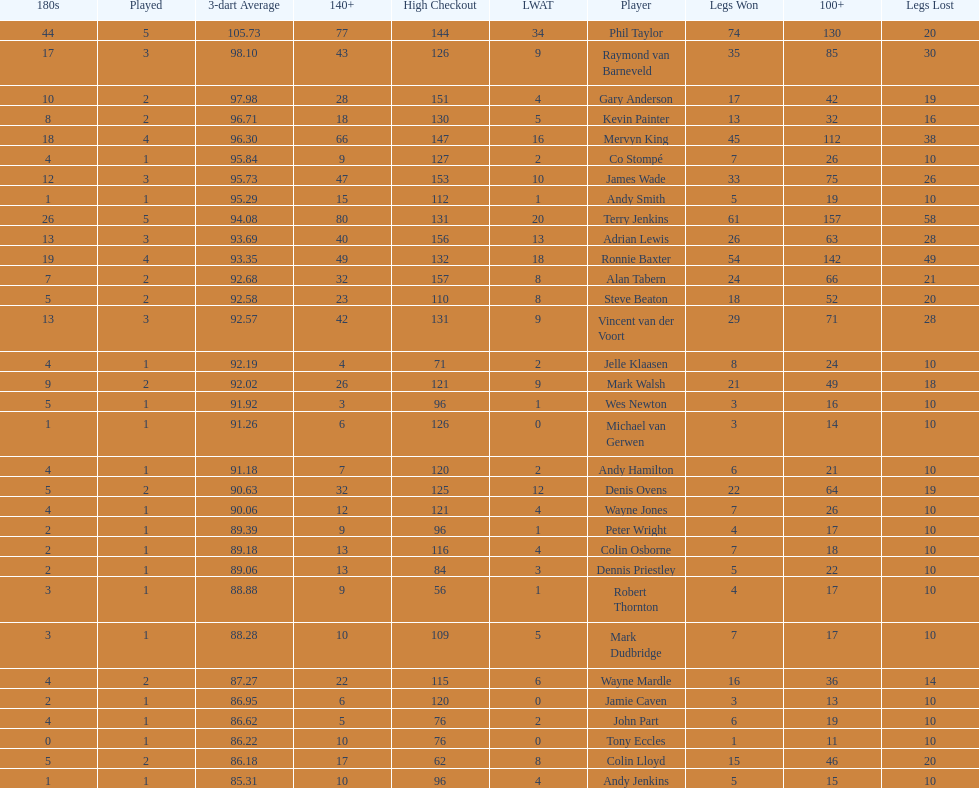Could you parse the entire table? {'header': ['180s', 'Played', '3-dart Average', '140+', 'High Checkout', 'LWAT', 'Player', 'Legs Won', '100+', 'Legs Lost'], 'rows': [['44', '5', '105.73', '77', '144', '34', 'Phil Taylor', '74', '130', '20'], ['17', '3', '98.10', '43', '126', '9', 'Raymond van Barneveld', '35', '85', '30'], ['10', '2', '97.98', '28', '151', '4', 'Gary Anderson', '17', '42', '19'], ['8', '2', '96.71', '18', '130', '5', 'Kevin Painter', '13', '32', '16'], ['18', '4', '96.30', '66', '147', '16', 'Mervyn King', '45', '112', '38'], ['4', '1', '95.84', '9', '127', '2', 'Co Stompé', '7', '26', '10'], ['12', '3', '95.73', '47', '153', '10', 'James Wade', '33', '75', '26'], ['1', '1', '95.29', '15', '112', '1', 'Andy Smith', '5', '19', '10'], ['26', '5', '94.08', '80', '131', '20', 'Terry Jenkins', '61', '157', '58'], ['13', '3', '93.69', '40', '156', '13', 'Adrian Lewis', '26', '63', '28'], ['19', '4', '93.35', '49', '132', '18', 'Ronnie Baxter', '54', '142', '49'], ['7', '2', '92.68', '32', '157', '8', 'Alan Tabern', '24', '66', '21'], ['5', '2', '92.58', '23', '110', '8', 'Steve Beaton', '18', '52', '20'], ['13', '3', '92.57', '42', '131', '9', 'Vincent van der Voort', '29', '71', '28'], ['4', '1', '92.19', '4', '71', '2', 'Jelle Klaasen', '8', '24', '10'], ['9', '2', '92.02', '26', '121', '9', 'Mark Walsh', '21', '49', '18'], ['5', '1', '91.92', '3', '96', '1', 'Wes Newton', '3', '16', '10'], ['1', '1', '91.26', '6', '126', '0', 'Michael van Gerwen', '3', '14', '10'], ['4', '1', '91.18', '7', '120', '2', 'Andy Hamilton', '6', '21', '10'], ['5', '2', '90.63', '32', '125', '12', 'Denis Ovens', '22', '64', '19'], ['4', '1', '90.06', '12', '121', '4', 'Wayne Jones', '7', '26', '10'], ['2', '1', '89.39', '9', '96', '1', 'Peter Wright', '4', '17', '10'], ['2', '1', '89.18', '13', '116', '4', 'Colin Osborne', '7', '18', '10'], ['2', '1', '89.06', '13', '84', '3', 'Dennis Priestley', '5', '22', '10'], ['3', '1', '88.88', '9', '56', '1', 'Robert Thornton', '4', '17', '10'], ['3', '1', '88.28', '10', '109', '5', 'Mark Dudbridge', '7', '17', '10'], ['4', '2', '87.27', '22', '115', '6', 'Wayne Mardle', '16', '36', '14'], ['2', '1', '86.95', '6', '120', '0', 'Jamie Caven', '3', '13', '10'], ['4', '1', '86.62', '5', '76', '2', 'John Part', '6', '19', '10'], ['0', '1', '86.22', '10', '76', '0', 'Tony Eccles', '1', '11', '10'], ['5', '2', '86.18', '17', '62', '8', 'Colin Lloyd', '15', '46', '20'], ['1', '1', '85.31', '10', '96', '4', 'Andy Jenkins', '5', '15', '10']]} Who won the highest number of legs in the 2009 world matchplay? Phil Taylor. 